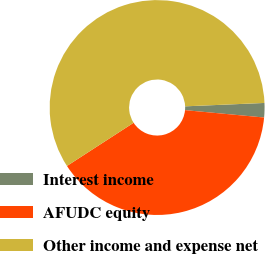Convert chart. <chart><loc_0><loc_0><loc_500><loc_500><pie_chart><fcel>Interest income<fcel>AFUDC equity<fcel>Other income and expense net<nl><fcel>2.16%<fcel>39.37%<fcel>58.47%<nl></chart> 